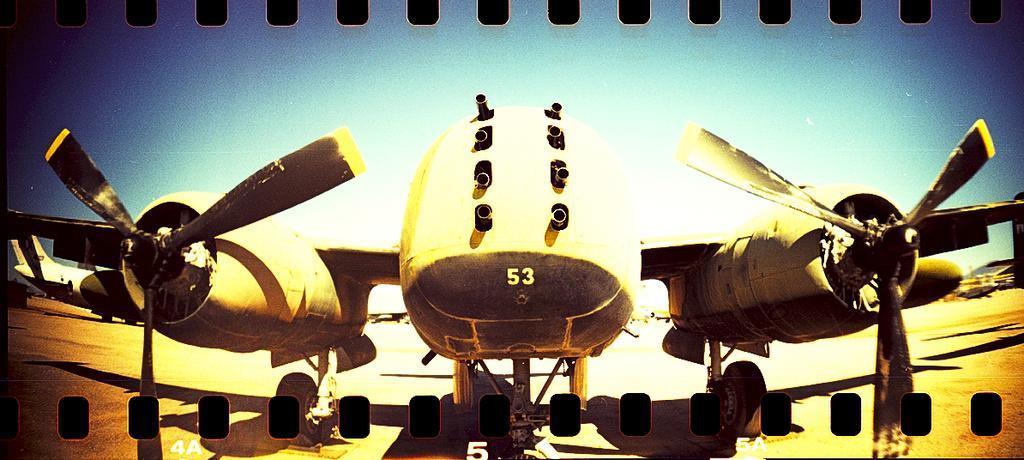Could you give a brief overview of what you see in this image? In this image we can see an aircraft. On the aircraft we can see some text. At the top we can see the sky. At the bottom we can see some text. 